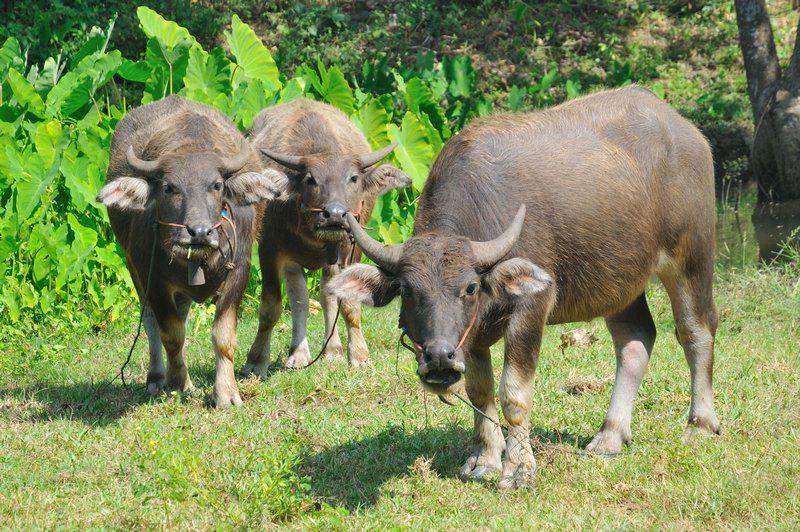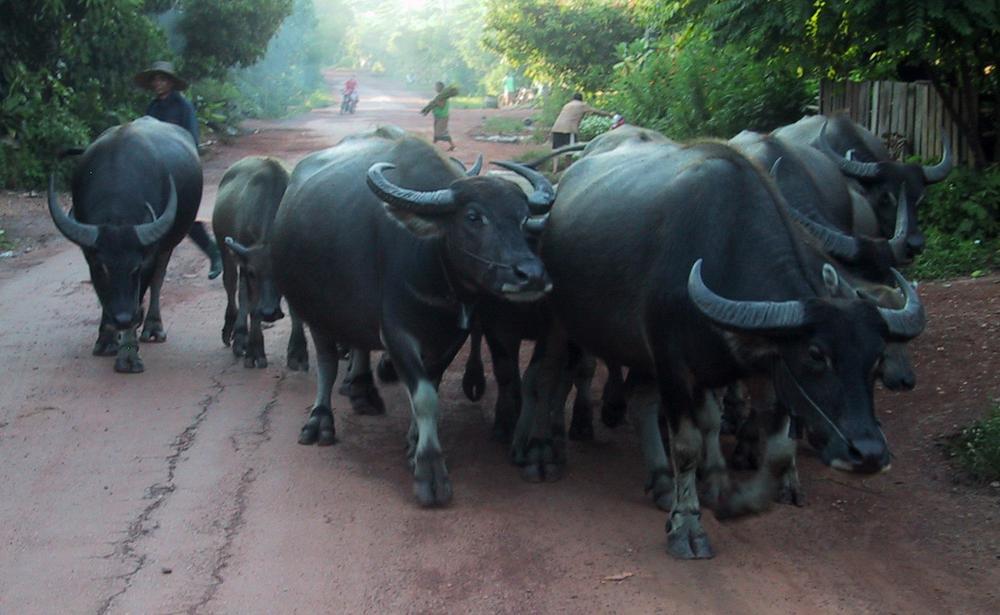The first image is the image on the left, the second image is the image on the right. For the images shown, is this caption "In each image, a rope can be seen threaded through the nose of at least one ox-like animal." true? Answer yes or no. Yes. The first image is the image on the left, the second image is the image on the right. Examine the images to the left and right. Is the description "The left image contains at least two water buffalo." accurate? Answer yes or no. Yes. 